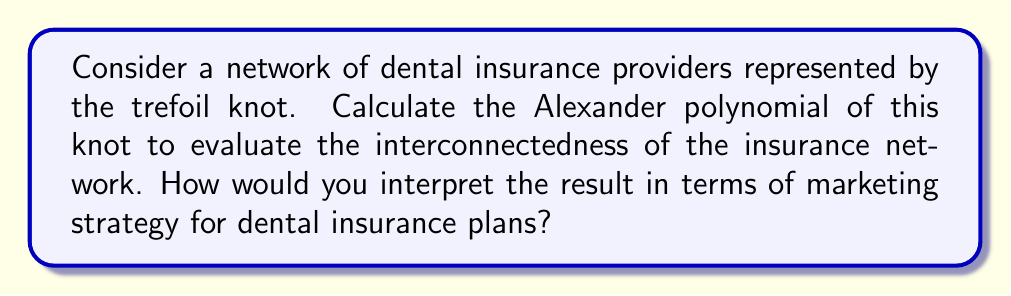Could you help me with this problem? To calculate the Alexander polynomial for the trefoil knot, we'll follow these steps:

1. First, we need to create a diagram of the trefoil knot and label the arcs and crossings:

[asy]
import geometry;

pair A=(0,1), B=(0.866,-0.5), C=(-0.866,-0.5);
draw(A--B--C--cycle,linewidth(2));
draw(A--C,linewidth(2));
draw(B--(0,-0.2),linewidth(2));
draw((0,-0.4)--C,linewidth(2));

label("x", (0.3,0.7), E);
label("y", (-0.3,0.7), W);
label("z", (0,-0.7), S);

label("1", (0.6,0.2), NE);
label("2", (-0.6,0.2), NW);
label("3", (0,-0.9), S);
[/asy]

2. Now, we create the Alexander matrix based on the labeled diagram:

$$
\begin{pmatrix}
1-t & -1 & t \\
t & 1-t & -1 \\
-1 & t & 1-t
\end{pmatrix}
$$

3. To find the Alexander polynomial, we calculate the determinant of any 2x2 minor of this matrix and divide by $(1-t)$. Let's use the first two rows and columns:

$$\Delta(t) = \frac{1}{1-t} \begin{vmatrix}
1-t & -1 \\
t & 1-t
\end{vmatrix}$$

4. Expand the determinant:

$$\Delta(t) = \frac{1}{1-t} ((1-t)(1-t) - (-1)(t))$$
$$\Delta(t) = \frac{1}{1-t} (1-2t+t^2+t)$$
$$\Delta(t) = \frac{1}{1-t} (1-t+t^2)$$

5. Simplify:

$$\Delta(t) = 1-t+t^2$$

Interpretation for marketing strategy:
The Alexander polynomial $1-t+t^2$ for the trefoil knot represents a complex, interconnected network of dental insurance providers. In marketing terms:

1. The constant term (1) represents the core market presence.
2. The negative linear term (-t) suggests potential competition or challenges in the market.
3. The positive quadratic term ($t^2$) indicates potential for growth and expansion.

This polynomial suggests a marketing strategy that focuses on:
a) Maintaining a strong core presence
b) Addressing competitive challenges
c) Capitalizing on growth opportunities in the dental insurance market
Answer: $\Delta(t) = 1-t+t^2$ 